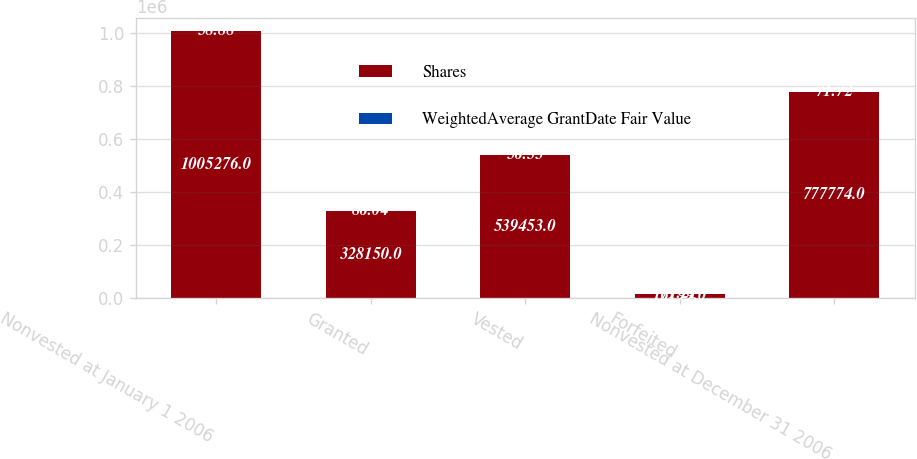Convert chart to OTSL. <chart><loc_0><loc_0><loc_500><loc_500><stacked_bar_chart><ecel><fcel>Nonvested at January 1 2006<fcel>Granted<fcel>Vested<fcel>Forfeited<fcel>Nonvested at December 31 2006<nl><fcel>Shares<fcel>1.00528e+06<fcel>328150<fcel>539453<fcel>16199<fcel>777774<nl><fcel>WeightedAverage GrantDate Fair Value<fcel>58.88<fcel>86.04<fcel>56.53<fcel>71.21<fcel>71.72<nl></chart> 